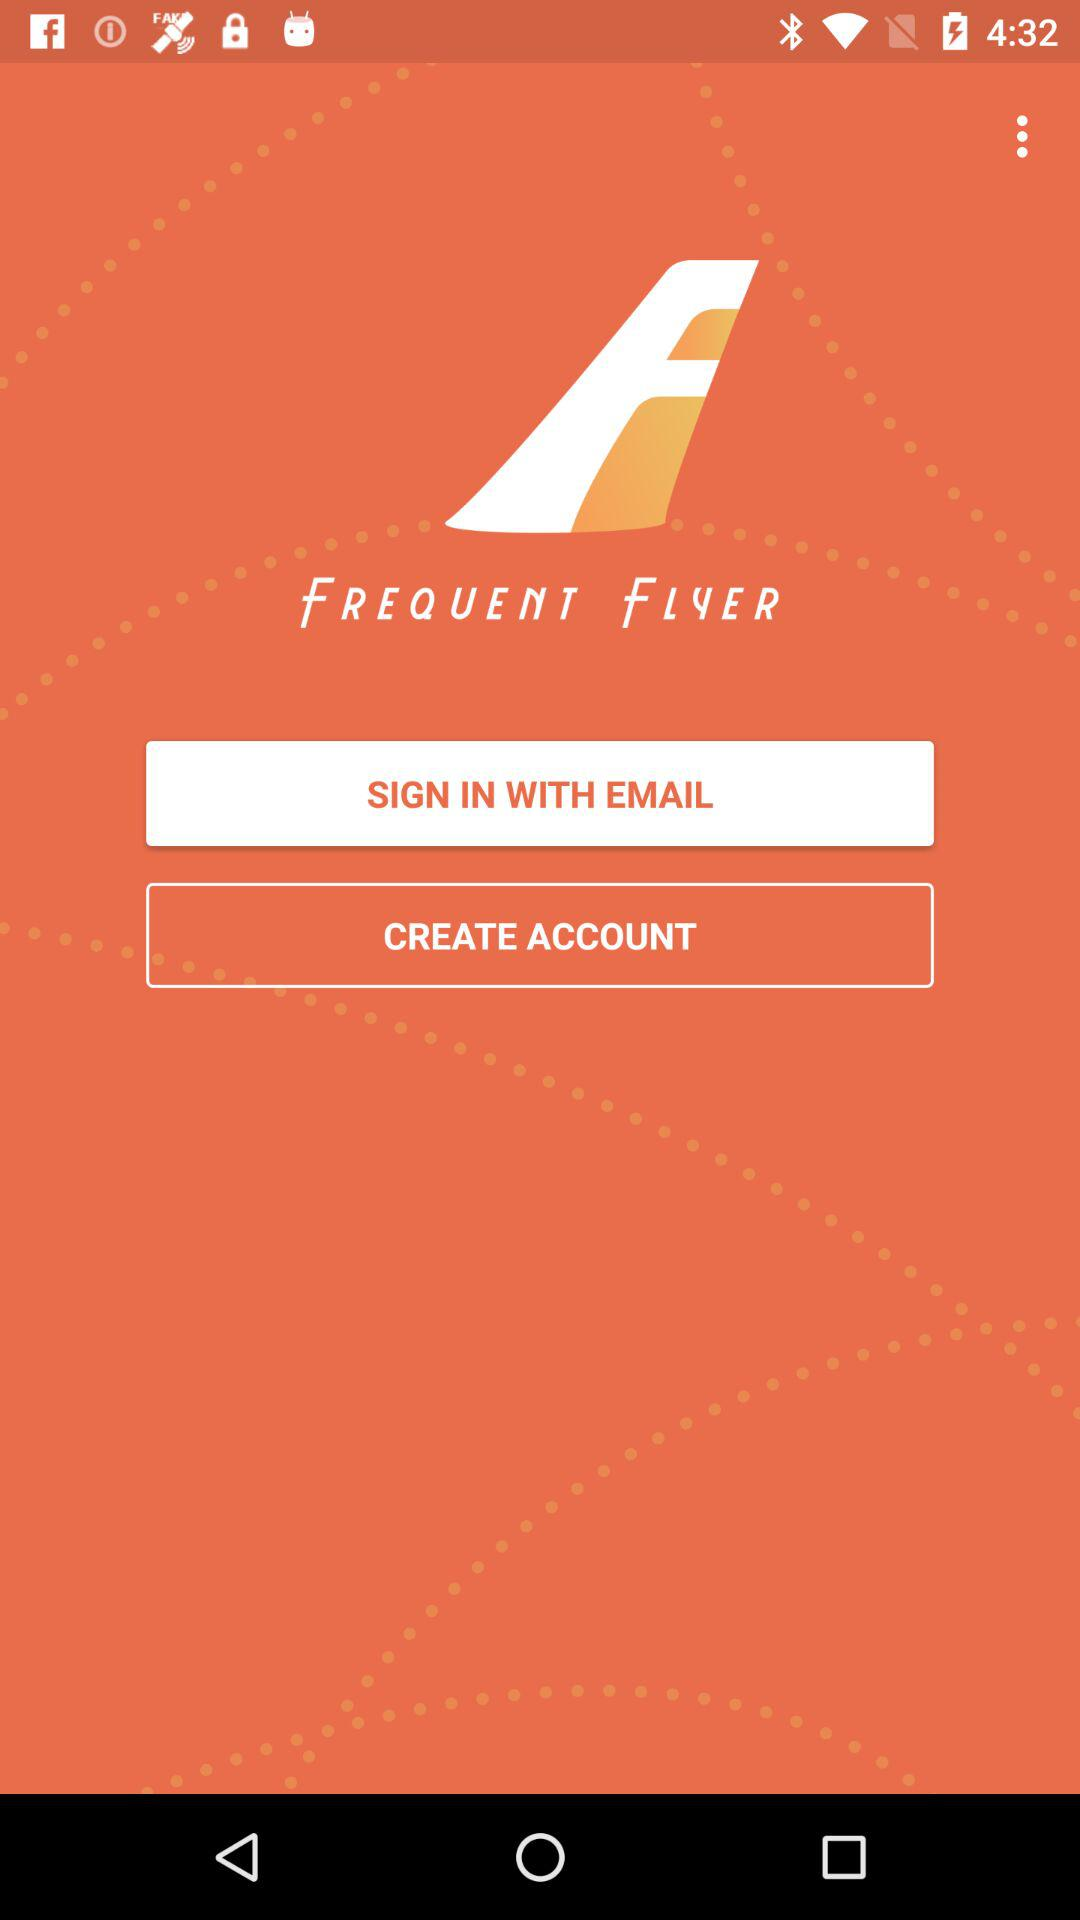What is the application name? The application name is "FREQUENT FLYER". 